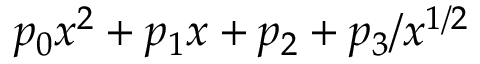Convert formula to latex. <formula><loc_0><loc_0><loc_500><loc_500>p _ { 0 } x ^ { 2 } + p _ { 1 } x + p _ { 2 } + p _ { 3 } / x ^ { 1 / 2 }</formula> 